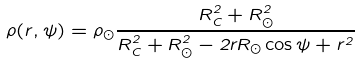Convert formula to latex. <formula><loc_0><loc_0><loc_500><loc_500>\rho ( r , \psi ) = \rho _ { \odot } \frac { R _ { C } ^ { 2 } + R _ { \odot } ^ { 2 } } { R _ { C } ^ { 2 } + R _ { \odot } ^ { 2 } - 2 r R _ { \odot } \cos \psi + r ^ { 2 } }</formula> 